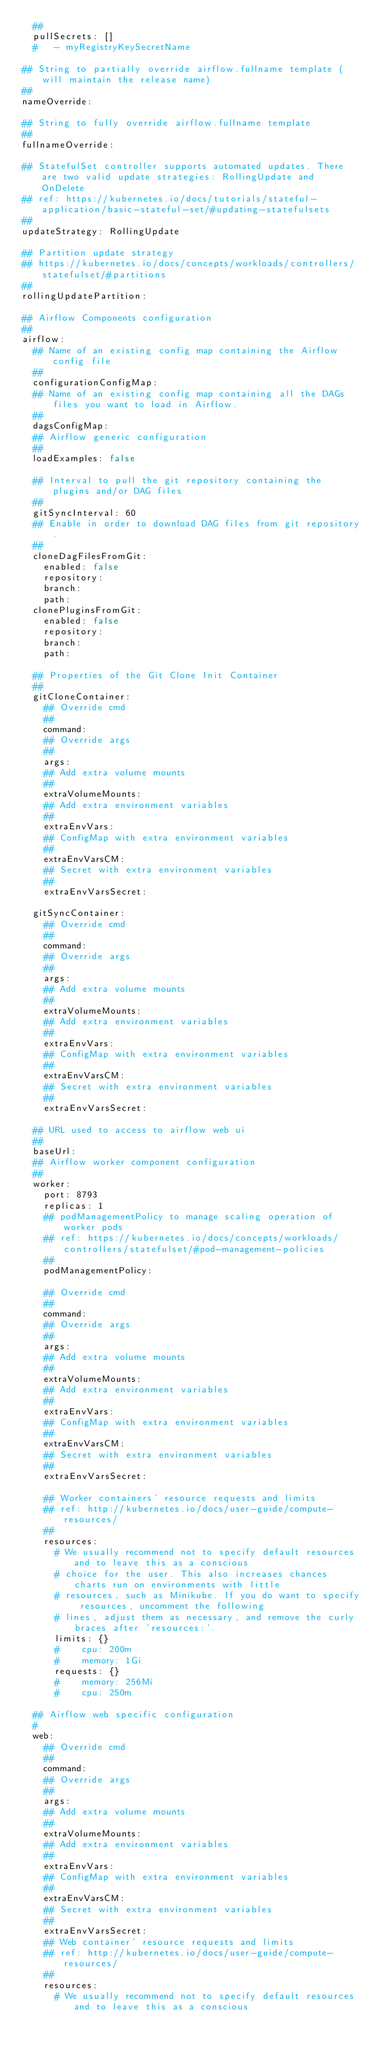Convert code to text. <code><loc_0><loc_0><loc_500><loc_500><_YAML_>  ##
  pullSecrets: []
  #   - myRegistryKeySecretName

## String to partially override airflow.fullname template (will maintain the release name)
##
nameOverride:

## String to fully override airflow.fullname template
##
fullnameOverride:

## StatefulSet controller supports automated updates. There are two valid update strategies: RollingUpdate and OnDelete
## ref: https://kubernetes.io/docs/tutorials/stateful-application/basic-stateful-set/#updating-statefulsets
##
updateStrategy: RollingUpdate

## Partition update strategy
## https://kubernetes.io/docs/concepts/workloads/controllers/statefulset/#partitions
##
rollingUpdatePartition:

## Airflow Components configuration
##
airflow:
  ## Name of an existing config map containing the Airflow config file
  ##
  configurationConfigMap:
  ## Name of an existing config map containing all the DAGs files you want to load in Airflow.
  ##
  dagsConfigMap:
  ## Airflow generic configuration
  ##
  loadExamples: false

  ## Interval to pull the git repository containing the plugins and/or DAG files
  ##
  gitSyncInterval: 60
  ## Enable in order to download DAG files from git repository.
  ##
  cloneDagFilesFromGit:
    enabled: false
    repository:
    branch:
    path:
  clonePluginsFromGit:
    enabled: false
    repository:
    branch:
    path:

  ## Properties of the Git Clone Init Container
  ##
  gitCloneContainer:
    ## Override cmd
    ##
    command:
    ## Override args
    ##
    args:
    ## Add extra volume mounts
    ##
    extraVolumeMounts:
    ## Add extra environment variables
    ##
    extraEnvVars:
    ## ConfigMap with extra environment variables
    ##
    extraEnvVarsCM:
    ## Secret with extra environment variables
    ##
    extraEnvVarsSecret:

  gitSyncContainer:
    ## Override cmd
    ##
    command:
    ## Override args
    ##
    args:
    ## Add extra volume mounts
    ##
    extraVolumeMounts:
    ## Add extra environment variables
    ##
    extraEnvVars:
    ## ConfigMap with extra environment variables
    ##
    extraEnvVarsCM:
    ## Secret with extra environment variables
    ##
    extraEnvVarsSecret:

  ## URL used to access to airflow web ui
  ##
  baseUrl:
  ## Airflow worker component configuration
  ##
  worker:
    port: 8793
    replicas: 1
    ## podManagementPolicy to manage scaling operation of worker pods
    ## ref: https://kubernetes.io/docs/concepts/workloads/controllers/statefulset/#pod-management-policies
    ##
    podManagementPolicy:

    ## Override cmd
    ##
    command:
    ## Override args
    ##
    args:
    ## Add extra volume mounts
    ##
    extraVolumeMounts:
    ## Add extra environment variables
    ##
    extraEnvVars:
    ## ConfigMap with extra environment variables
    ##
    extraEnvVarsCM:
    ## Secret with extra environment variables
    ##
    extraEnvVarsSecret:

    ## Worker containers' resource requests and limits
    ## ref: http://kubernetes.io/docs/user-guide/compute-resources/
    ##
    resources:
      # We usually recommend not to specify default resources and to leave this as a conscious
      # choice for the user. This also increases chances charts run on environments with little
      # resources, such as Minikube. If you do want to specify resources, uncomment the following
      # lines, adjust them as necessary, and remove the curly braces after 'resources:'.
      limits: {}
      #    cpu: 200m
      #    memory: 1Gi
      requests: {}
      #    memory: 256Mi
      #    cpu: 250m

  ## Airflow web specific configuration
  #
  web:
    ## Override cmd
    ##
    command:
    ## Override args
    ##
    args:
    ## Add extra volume mounts
    ##
    extraVolumeMounts:
    ## Add extra environment variables
    ##
    extraEnvVars:
    ## ConfigMap with extra environment variables
    ##
    extraEnvVarsCM:
    ## Secret with extra environment variables
    ##
    extraEnvVarsSecret:
    ## Web container' resource requests and limits
    ## ref: http://kubernetes.io/docs/user-guide/compute-resources/
    ##
    resources:
      # We usually recommend not to specify default resources and to leave this as a conscious</code> 